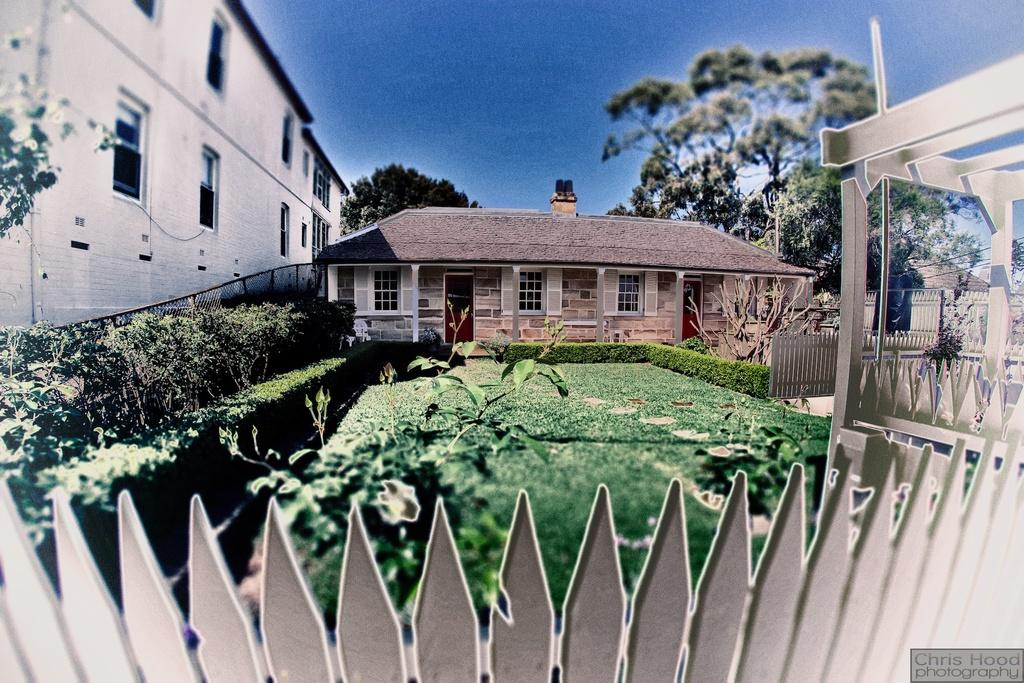What type of structure can be seen in the image? There is fencing in the image. What type of vegetation is present in the image? There is grass and plants in the image. What can be seen in the background of the image? There are houses, trees, and the sky in the background of the image. What is the topic of the discussion taking place in the image? There is no discussion taking place in the image; it is a still image. Can you describe the crack in the fencing in the image? There is no crack in the fencing in the image; the fencing appears to be in good condition. 